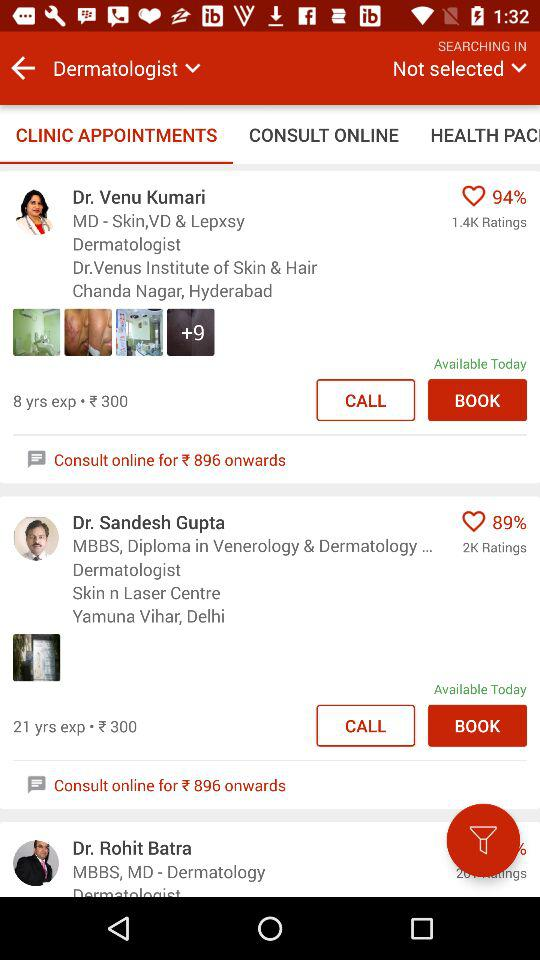What are the qualifications of Dr. Sandesh Gupta? The qualifications of Dr. Sandesh Gupta are "MBBS, Diploma in Venerology & Dermatology...". 